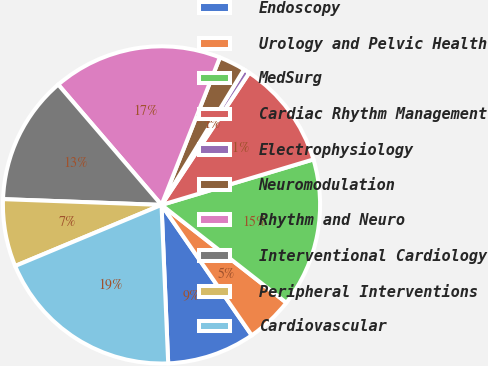<chart> <loc_0><loc_0><loc_500><loc_500><pie_chart><fcel>Endoscopy<fcel>Urology and Pelvic Health<fcel>MedSurg<fcel>Cardiac Rhythm Management<fcel>Electrophysiology<fcel>Neuromodulation<fcel>Rhythm and Neuro<fcel>Interventional Cardiology<fcel>Peripheral Interventions<fcel>Cardiovascular<nl><fcel>8.96%<fcel>4.79%<fcel>15.21%<fcel>11.04%<fcel>0.62%<fcel>2.71%<fcel>17.29%<fcel>13.13%<fcel>6.87%<fcel>19.38%<nl></chart> 